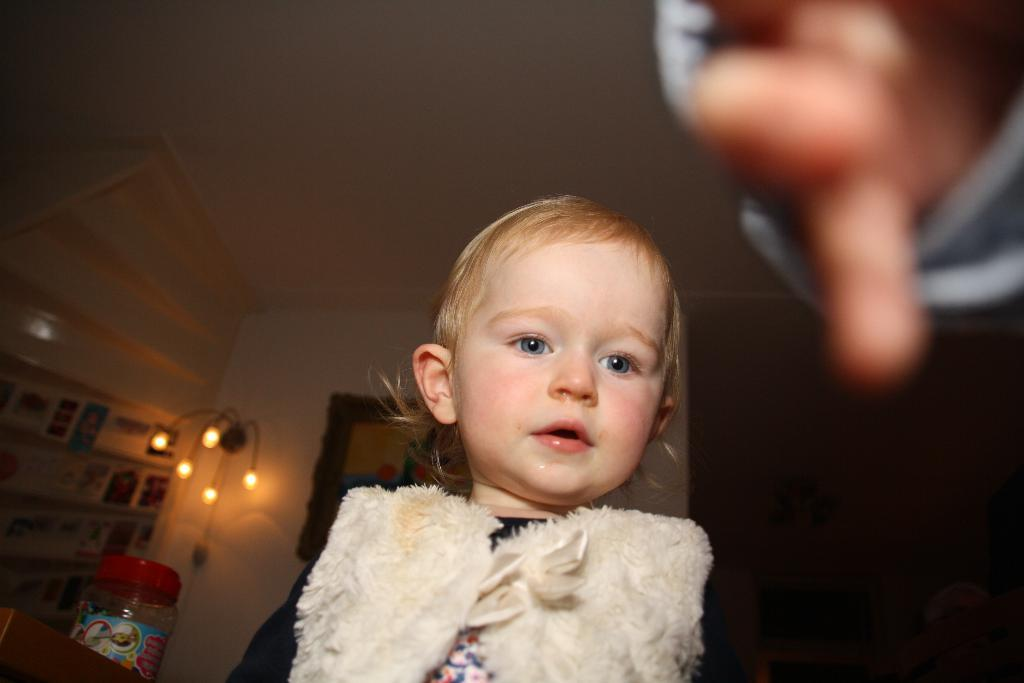What is the main subject of the image? There is a kid in the image. Can you describe any other elements in the image? A person's hand is visible in the image, and there are objects on shelves. What type of lighting is present in the image? There are lights visible in the image. What is one specific object that can be seen in the image? There is a bottle in the image. What is in the background of the image? There is a wall in the background of the image. What type of trousers is the kid wearing in the image? The provided facts do not mention the type of trousers the kid is wearing, so we cannot answer this question definitively. Are there any marbles visible in the image? There is no mention of marbles in the provided facts, so we cannot answer this question definitively. 